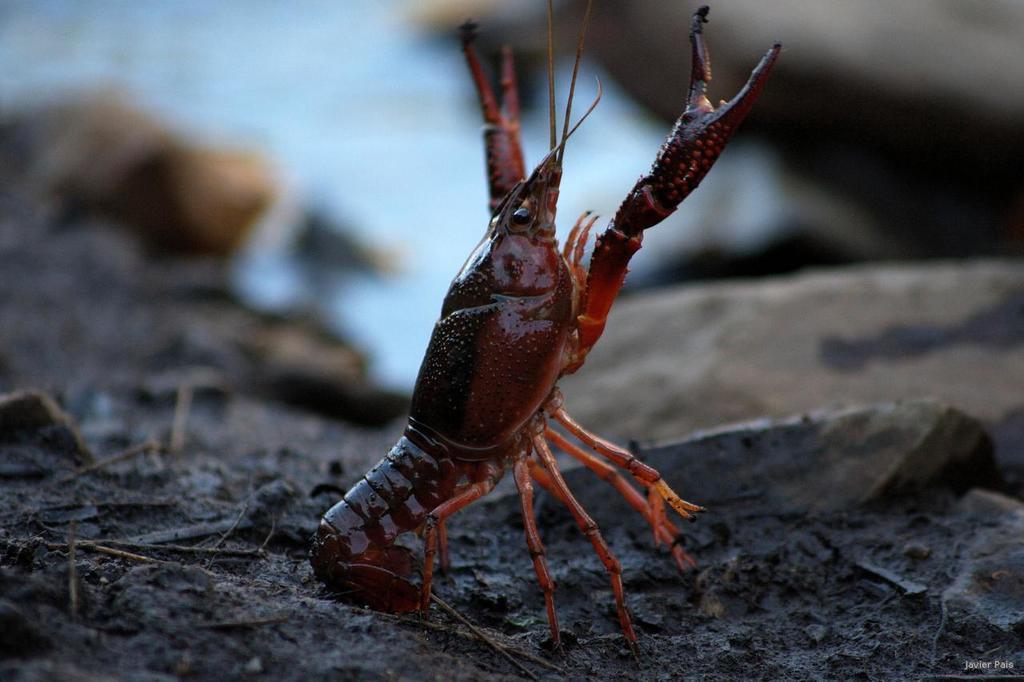Could you give a brief overview of what you see in this image? In this picture there is a scorpion standing on the ground. Here we can see stone. 